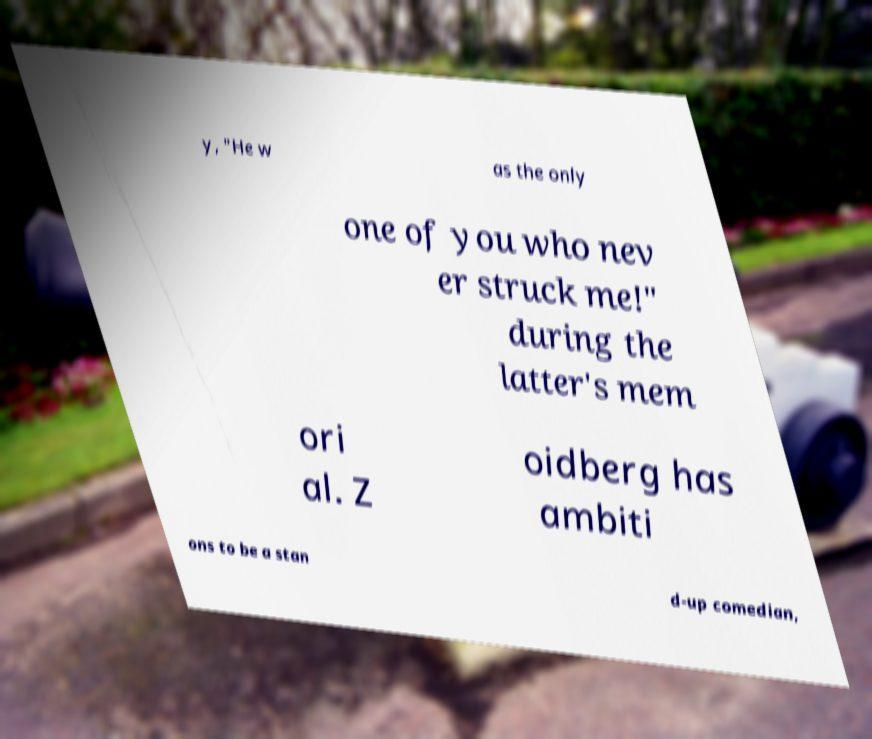Please read and relay the text visible in this image. What does it say? y, "He w as the only one of you who nev er struck me!" during the latter's mem ori al. Z oidberg has ambiti ons to be a stan d-up comedian, 